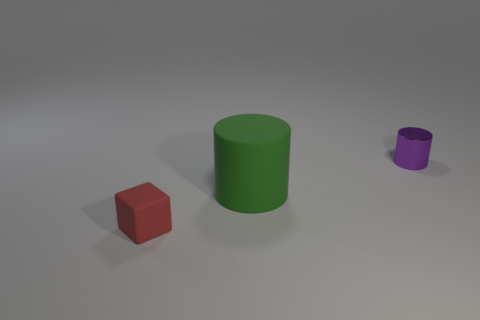How could the shadows give us clues about the light source in this scene? The shadows cast by the objects on the ground give us valuable information about the light source. They are relatively soft and extend towards the bottom-left corner of the image, suggesting the light source is positioned to the top-right of the scene. The length and angle of the shadows could indicate that the light source is not overly close to the objects, possibly simulating a natural light situation like sunlight or ambient daylight in an indoor setting. 